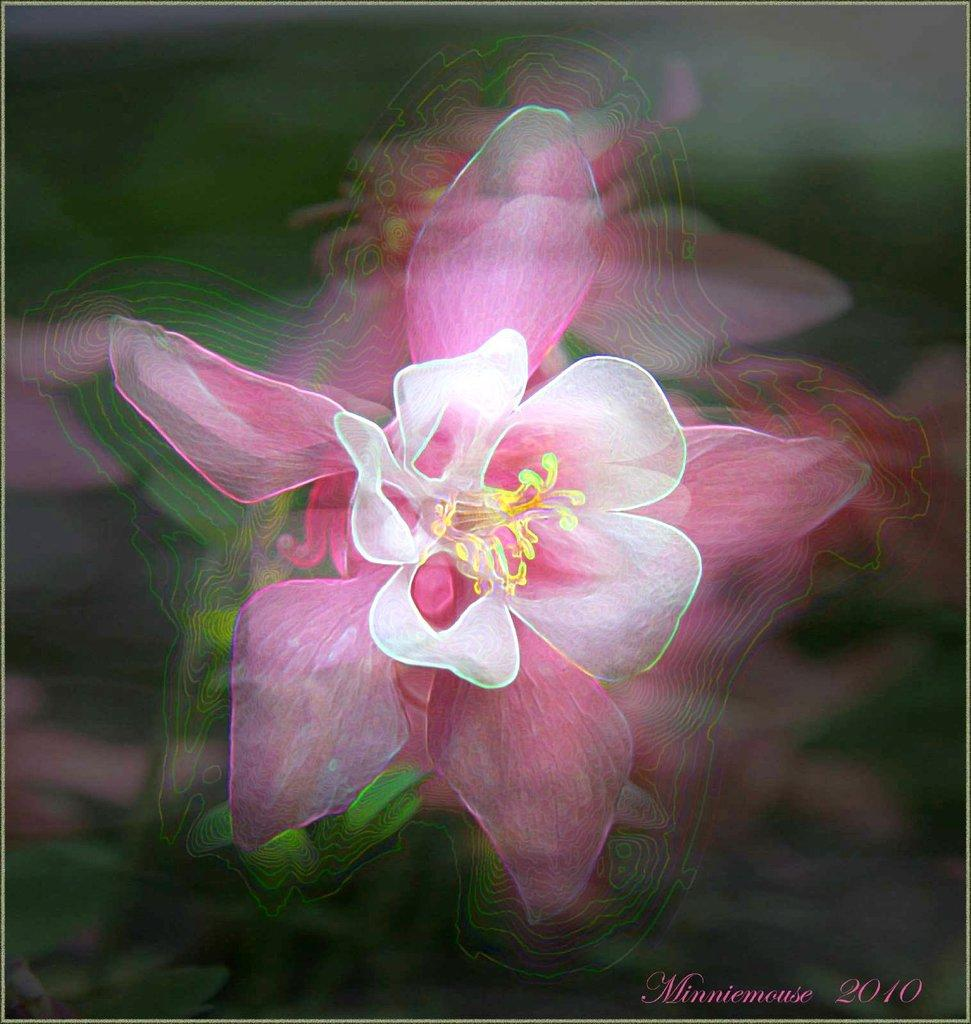What is the main subject of the image? There is a flower in the image. Can you describe the background of the image? The background of the image is blurry. Where can we find additional information in the image? There is text and a year in the bottom right side of the image. How does the flower show respect to the wind in the image? There is no wind present in the image, and the flower does not show respect to the wind. 